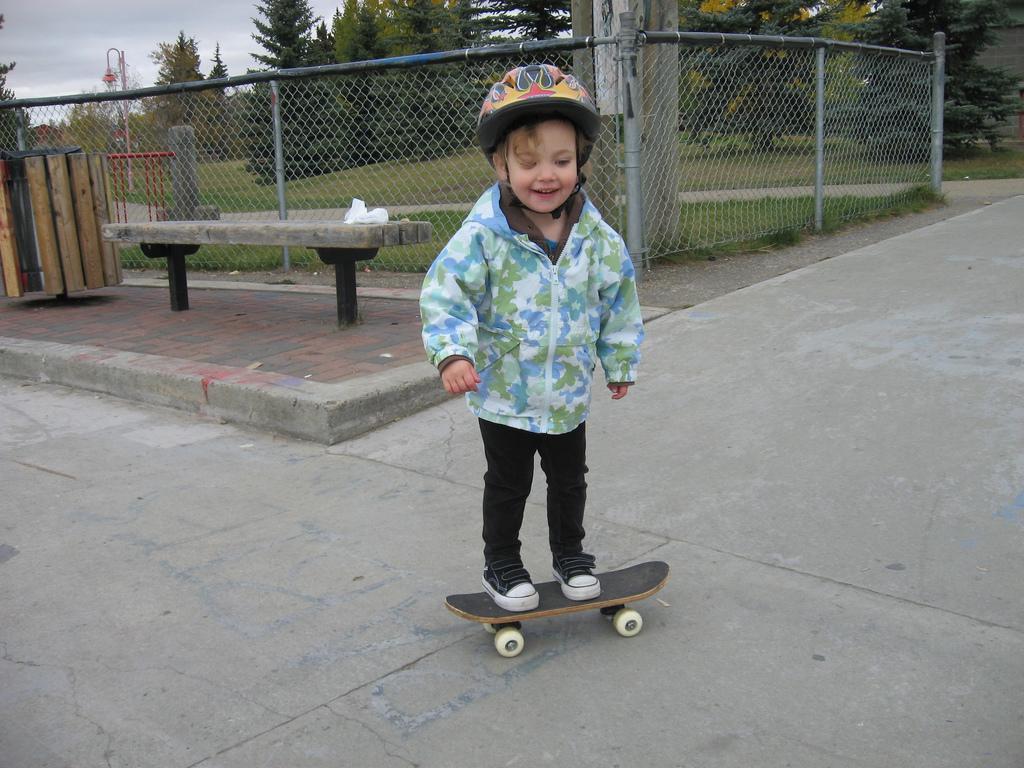Describe this image in one or two sentences. This is a picture near a playground. In the center of the picture there is a kid on the skateboard. In the background there is a fencing and trees. Sky is cloudy. On the left there is a pavement and a bench. 